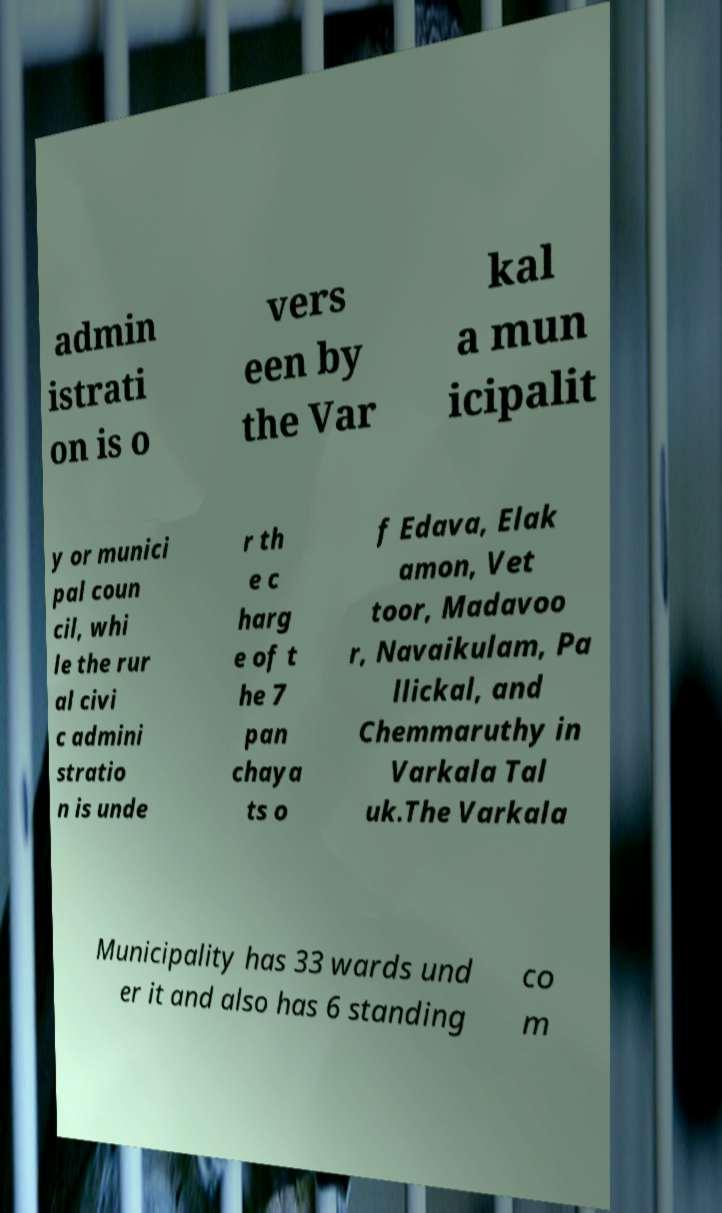Can you accurately transcribe the text from the provided image for me? admin istrati on is o vers een by the Var kal a mun icipalit y or munici pal coun cil, whi le the rur al civi c admini stratio n is unde r th e c harg e of t he 7 pan chaya ts o f Edava, Elak amon, Vet toor, Madavoo r, Navaikulam, Pa llickal, and Chemmaruthy in Varkala Tal uk.The Varkala Municipality has 33 wards und er it and also has 6 standing co m 